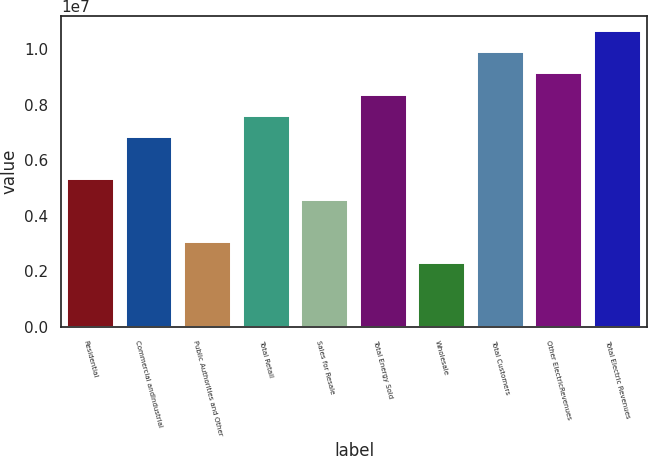<chart> <loc_0><loc_0><loc_500><loc_500><bar_chart><fcel>Residential<fcel>Commercial andIndustrial<fcel>Public Authorities and Other<fcel>Total Retail<fcel>Sales for Resale<fcel>Total Energy Sold<fcel>Wholesale<fcel>Total Customers<fcel>Other ElectricRevenues<fcel>Total Electric Revenues<nl><fcel>5.32561e+06<fcel>6.84722e+06<fcel>3.04321e+06<fcel>7.60802e+06<fcel>4.56481e+06<fcel>8.36882e+06<fcel>2.28241e+06<fcel>9.89042e+06<fcel>9.12962e+06<fcel>1.06512e+07<nl></chart> 